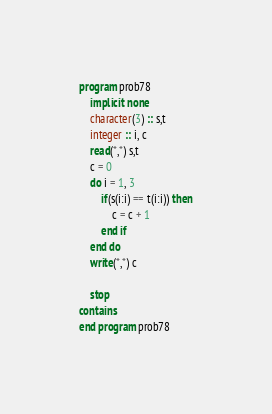Convert code to text. <code><loc_0><loc_0><loc_500><loc_500><_FORTRAN_>program prob78
    implicit none
    character(3) :: s,t
    integer :: i, c
    read(*,*) s,t
    c = 0
    do i = 1, 3
        if(s(i:i) == t(i:i)) then
            c = c + 1
        end if
    end do
    write(*,*) c

    stop
contains
end program prob78</code> 